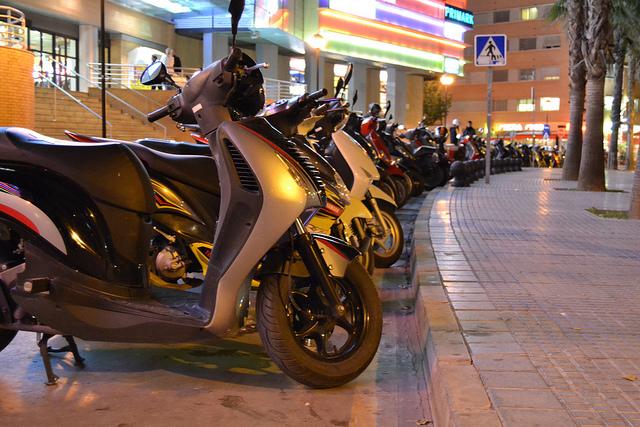What would happen if someone pushed the nearest motorcycle?
Answer briefly. Domino effect. What material is the sidewalk made of?
Keep it brief. Brick. What kind of trees are on the far right?
Be succinct. Palm. 